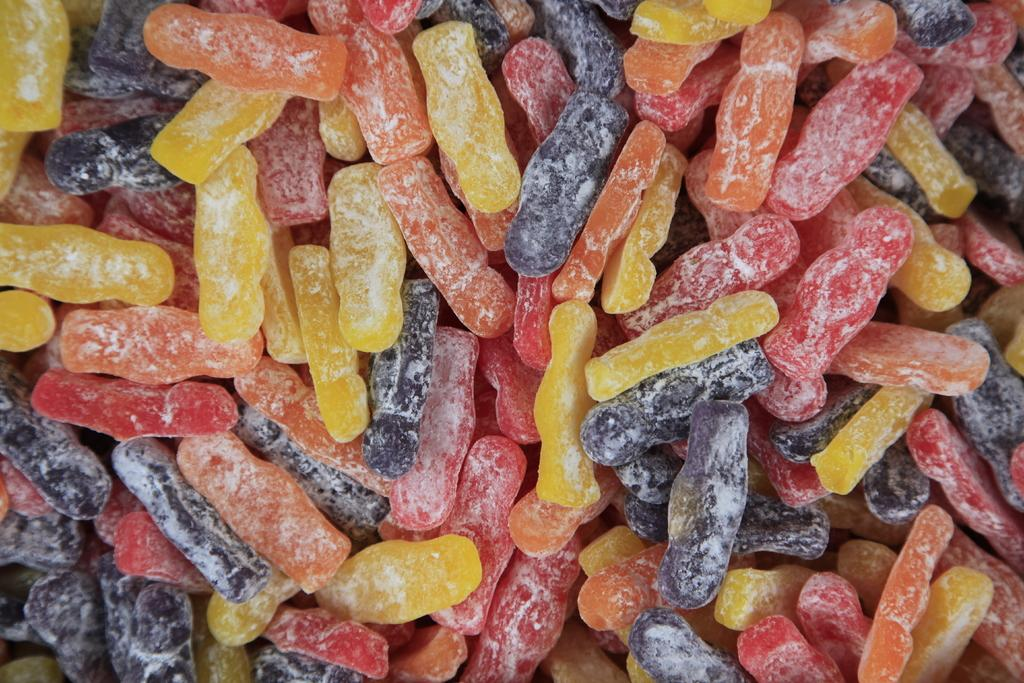What type of candies are in the image? There is a group of gummy candies in the image. Can you describe the appearance of the candies? The gummy candies are colorful and shaped like various fruits or animals. How are the candies arranged in the image? The gummy candies are arranged in a cluster or group. What type of medical treatment is being administered at the hospital in the image? There is no hospital or medical treatment present in the image; it only features a group of gummy candies. 